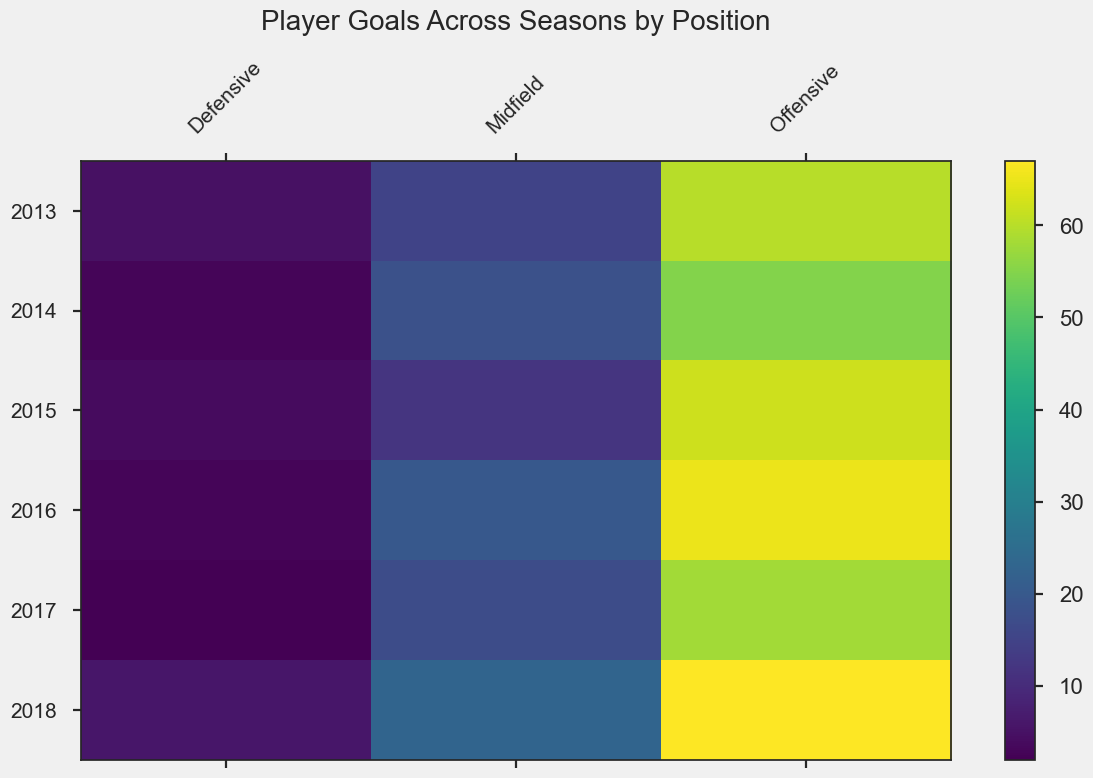Which position scored the most goals in the 2018 season? Visually inspect the heatmap for the 2018 season and find the position with the highest color intensity (since higher values correspond to brighter colors). The Offensive position stands out.
Answer: Offensive Comparing the 2015 and 2016 seasons, did the Defensive position's goals increase, decrease, or stay the same? Look at the color intensity for the Defensive position in both years. The 2016 value (darker color) is less than that in 2015 (slightly brighter color), indicating a decrease.
Answer: Decrease Across which seasons did the Midfield position score a consistent number of goals? Identify the seasons where the Midfield's color intensity remains similar. Seasons 2014, 2017, and 2015 have close color intensities for Midfield.
Answer: 2014, 2017, 2015 What's the total number of goals scored by the Offensive position over the 2014 and 2015 seasons? Sum the values for the Offensive position in both 2014 (55 goals) and 2015 (62 goals). The total is 55 + 62 = 117.
Answer: 117 Which season had the lowest goal count for the Defensive position? Visually scan all seasons' color intensities for the Defensive position and identify the darkest cell. The 2017 season has the darkest cell for Defensive.
Answer: 2017 Does the Midfield position show an increasing trend in goals scored from 2013 to 2018? Observe the color intensity trend for Midfield from 2013 to 2018. Although there are fluctuations, the color gets progressively lighter, indicating a general increase in goals.
Answer: Yes How much greater were the goals scored by Offensive position compared to Defensive position in 2016? Look at the values for 2016: Offensive scored 65 goals, Defensive scored 3 goals. The difference is 65 - 3 = 62.
Answer: 62 Determine the average number of goals scored by the Offensive position from 2013 to 2018. Sum the values for the Offensive position across the years: 60 + 55 + 62 + 65 + 58 + 67 = 367. Divide by the number of years (6) for the average: 367 / 6 ≈ 61.17.
Answer: 61.17 